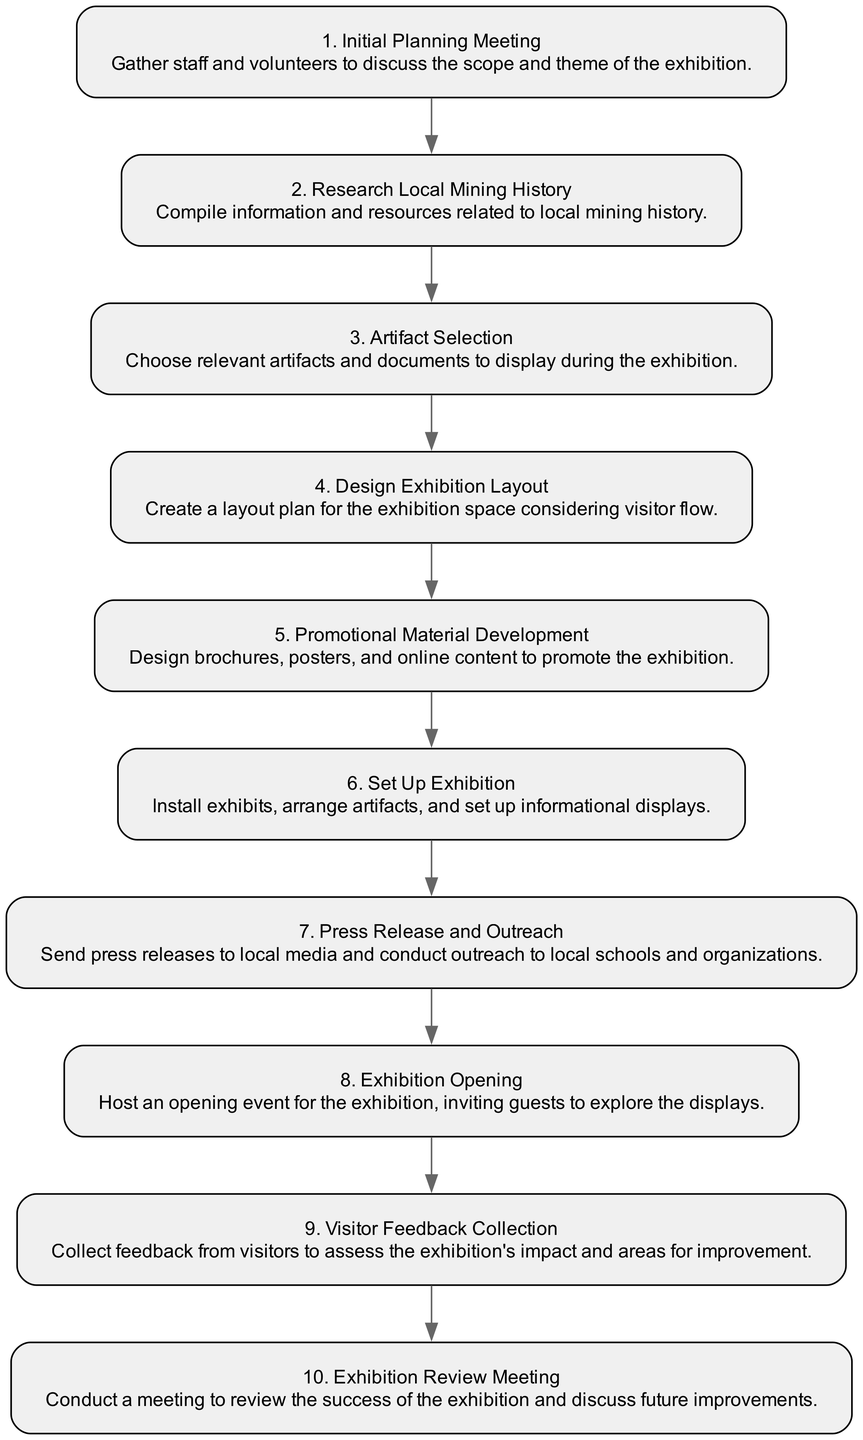What is the first step in the sequence? The first step listed in the diagram is "Initial Planning Meeting." It is the first event that occurs in organizing the exhibition.
Answer: Initial Planning Meeting How many steps are there in total? By counting the nodes in the sequence, there are ten distinct steps that outline the process of organizing the exhibition.
Answer: 10 What step comes immediately after "Artifact Selection"? According to the flow in the sequence diagram, the step that follows "Artifact Selection" is "Design Exhibition Layout." This indicates that the layout design occurs right after selecting artifacts.
Answer: Design Exhibition Layout Which step involves reaching out to local media? The step that involves reaching out to local media is called "Press Release and Outreach." This step is focused on promoting the exhibition through communication channels.
Answer: Press Release and Outreach What is the final step of the exhibition organization sequence? The last step in the sequence is "Exhibition Review Meeting." This concludes the process by evaluating the success of the exhibition and deciding on future improvements.
Answer: Exhibition Review Meeting How are the steps organized in the diagram? The steps are organized in a sequence from the initial planning to final review, indicating a chronological flow of events in organizing the exhibition. Each step logically follows the previous one, outlining a clear process.
Answer: Chronological order Which step precedes "Set Up Exhibition"? "Promotional Material Development" directly precedes "Set Up Exhibition," indicating that promotional efforts are completed before the physical setup of the exhibition takes place.
Answer: Promotional Material Development Does the diagram show any parallel steps? The sequence diagram does not indicate any parallel steps; all steps are arranged in a linear fashion, leading one to the next without any branching.
Answer: No What is the purpose of "Visitor Feedback Collection"? The purpose of "Visitor Feedback Collection" is to gather insights from visitors about their experience at the exhibition, assessing both its impact and areas that could be improved upon.
Answer: Assess exhibition impact 